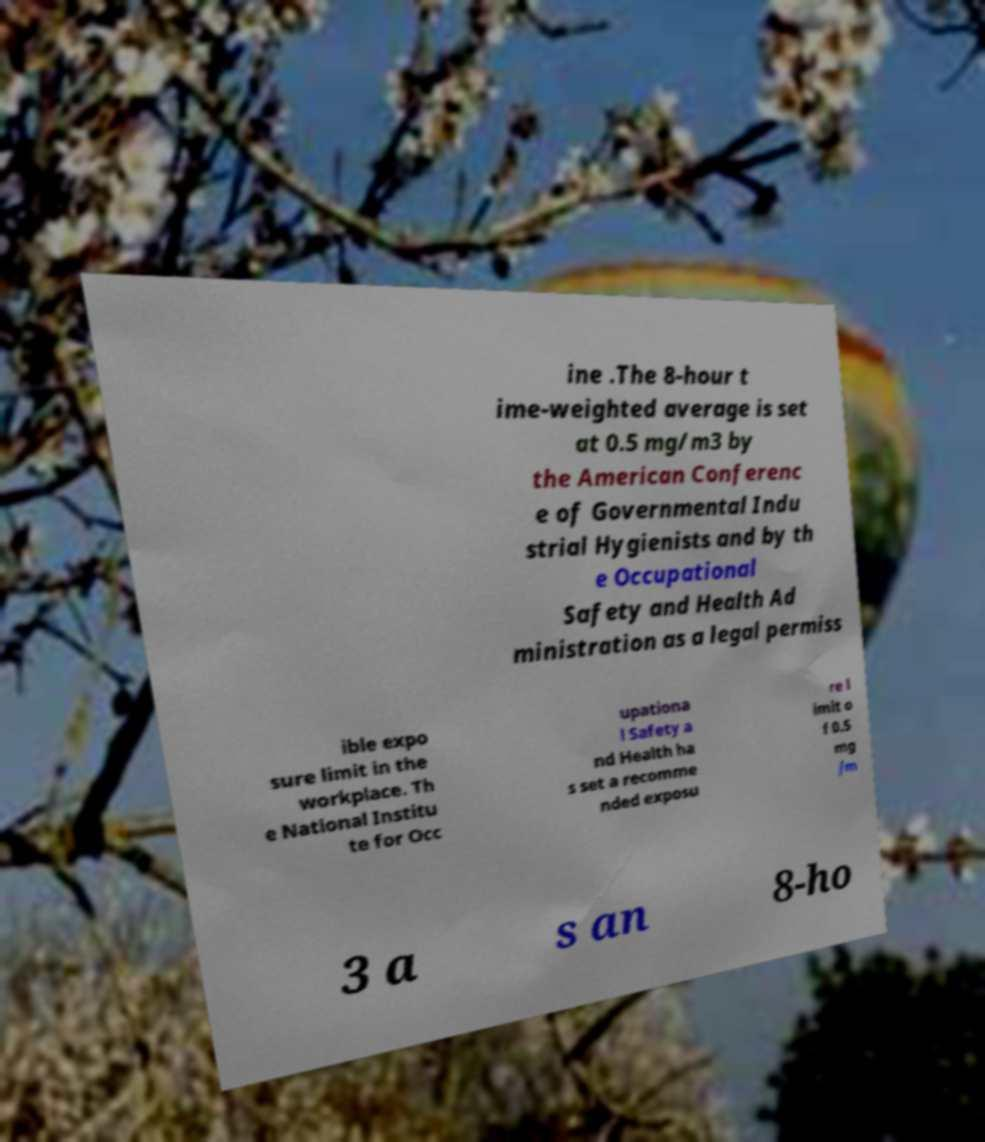Could you extract and type out the text from this image? ine .The 8-hour t ime-weighted average is set at 0.5 mg/m3 by the American Conferenc e of Governmental Indu strial Hygienists and by th e Occupational Safety and Health Ad ministration as a legal permiss ible expo sure limit in the workplace. Th e National Institu te for Occ upationa l Safety a nd Health ha s set a recomme nded exposu re l imit o f 0.5 mg /m 3 a s an 8-ho 